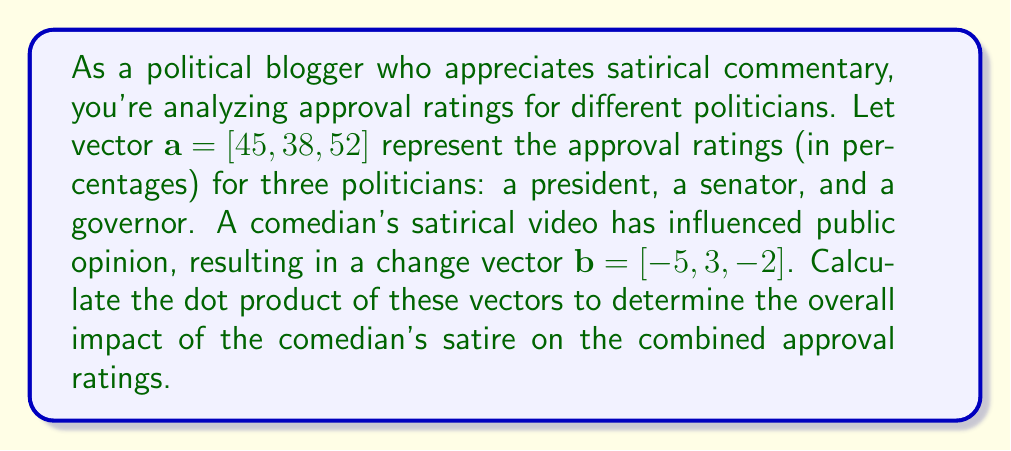Show me your answer to this math problem. To solve this problem, we need to calculate the dot product of vectors $\mathbf{a}$ and $\mathbf{b}$. The dot product is defined as the sum of the products of corresponding elements in two vectors.

Given:
$\mathbf{a} = [45, 38, 52]$
$\mathbf{b} = [-5, 3, -2]$

The dot product formula for two 3-dimensional vectors is:

$$\mathbf{a} \cdot \mathbf{b} = a_1b_1 + a_2b_2 + a_3b_3$$

Let's calculate each term:

1. $a_1b_1 = 45 \times (-5) = -225$
2. $a_2b_2 = 38 \times 3 = 114$
3. $a_3b_3 = 52 \times (-2) = -104$

Now, we sum these products:

$$\mathbf{a} \cdot \mathbf{b} = -225 + 114 + (-104) = -215$$

The negative result indicates that the comedian's satire has an overall negative impact on the combined approval ratings of the three politicians.
Answer: $-215$ 